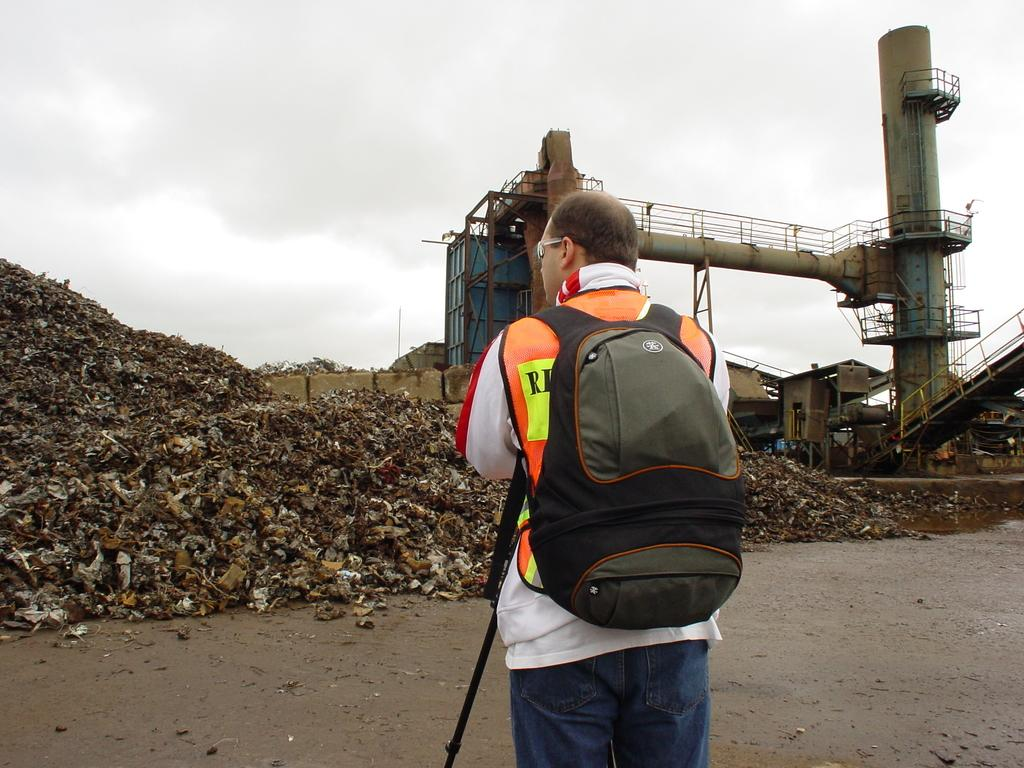Where was the image taken? The image is taken outdoors. Who is present in the image? There is a man in the image. What is the man wearing? The man is wearing a white jacket. What is the man holding in the image? The man is holding a stick. What is the man carrying on his back? The man is wearing a bag. What is in front of the man? There is garbage and a machine in front of the man. What can be seen in the sky in the image? The sky is visible in the image. How many babies are crawling around the man in the image? There are no babies present in the image. What type of writer is standing next to the man in the image? There is no writer present in the image. 